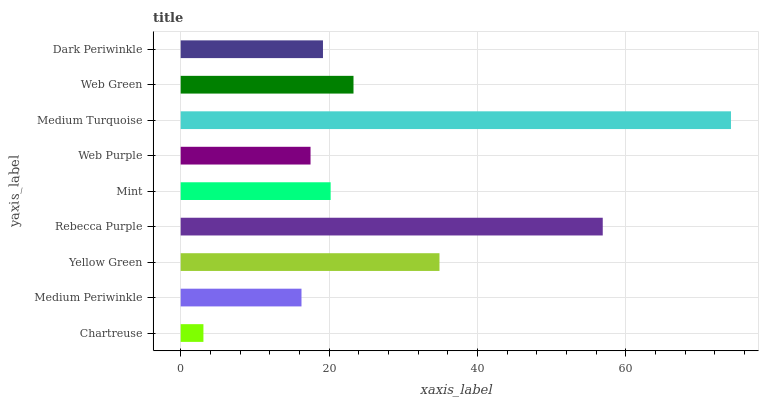Is Chartreuse the minimum?
Answer yes or no. Yes. Is Medium Turquoise the maximum?
Answer yes or no. Yes. Is Medium Periwinkle the minimum?
Answer yes or no. No. Is Medium Periwinkle the maximum?
Answer yes or no. No. Is Medium Periwinkle greater than Chartreuse?
Answer yes or no. Yes. Is Chartreuse less than Medium Periwinkle?
Answer yes or no. Yes. Is Chartreuse greater than Medium Periwinkle?
Answer yes or no. No. Is Medium Periwinkle less than Chartreuse?
Answer yes or no. No. Is Mint the high median?
Answer yes or no. Yes. Is Mint the low median?
Answer yes or no. Yes. Is Medium Periwinkle the high median?
Answer yes or no. No. Is Dark Periwinkle the low median?
Answer yes or no. No. 